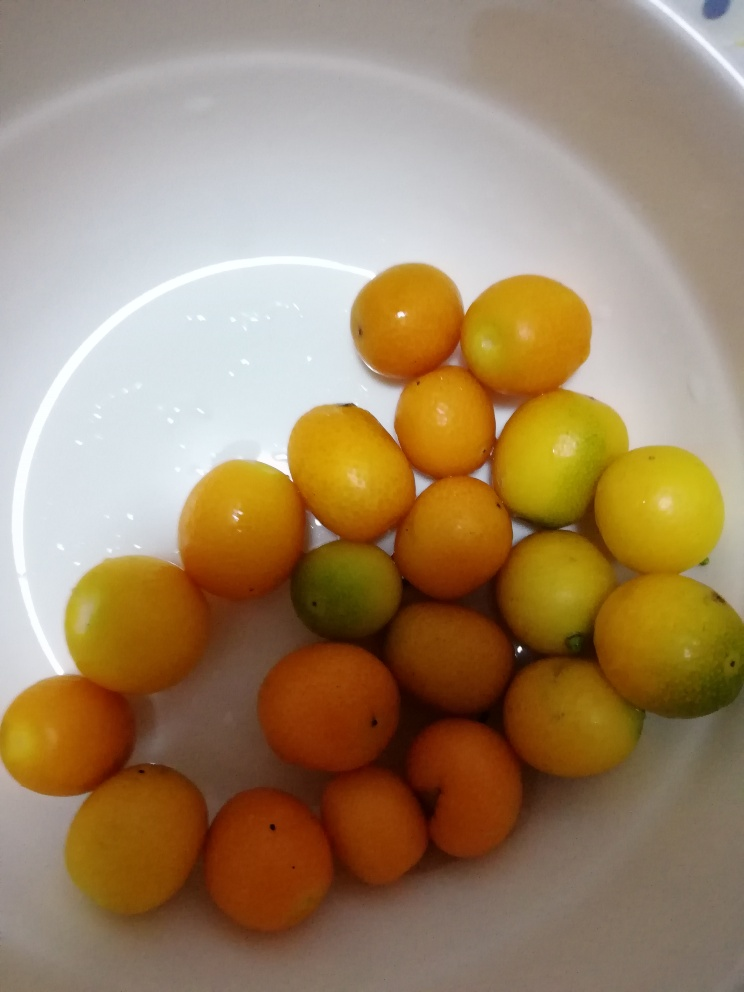These fruits seem perfect for a recipe. Can you suggest one that would be a good fit? Certainly! Given their size and flavor profile, these fruits would be excellent in a summer citrus salad. You could slice them thinly and mix them with a drizzle of honey, a sprinkle of fresh mint, and a dash of balsamic vinegar for a refreshing and tangy dish. 